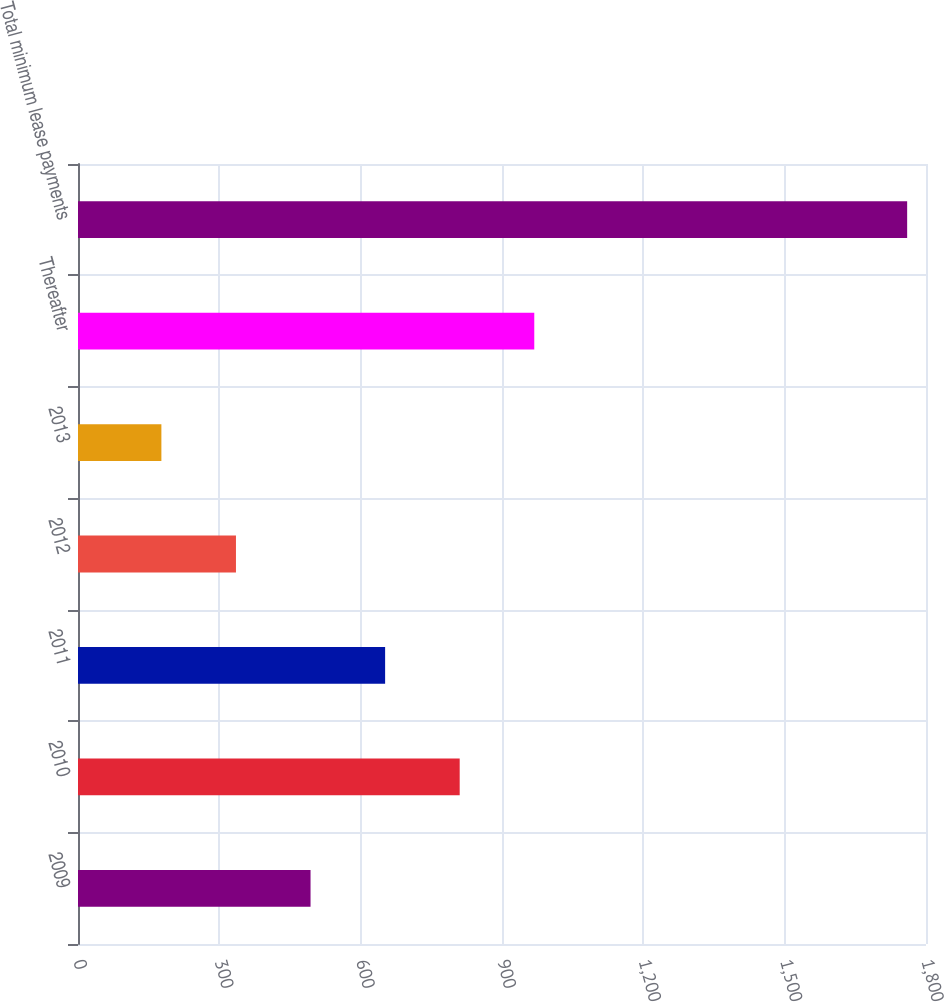Convert chart to OTSL. <chart><loc_0><loc_0><loc_500><loc_500><bar_chart><fcel>2009<fcel>2010<fcel>2011<fcel>2012<fcel>2013<fcel>Thereafter<fcel>Total minimum lease payments<nl><fcel>493.6<fcel>810.2<fcel>651.9<fcel>335.3<fcel>177<fcel>968.5<fcel>1760<nl></chart> 